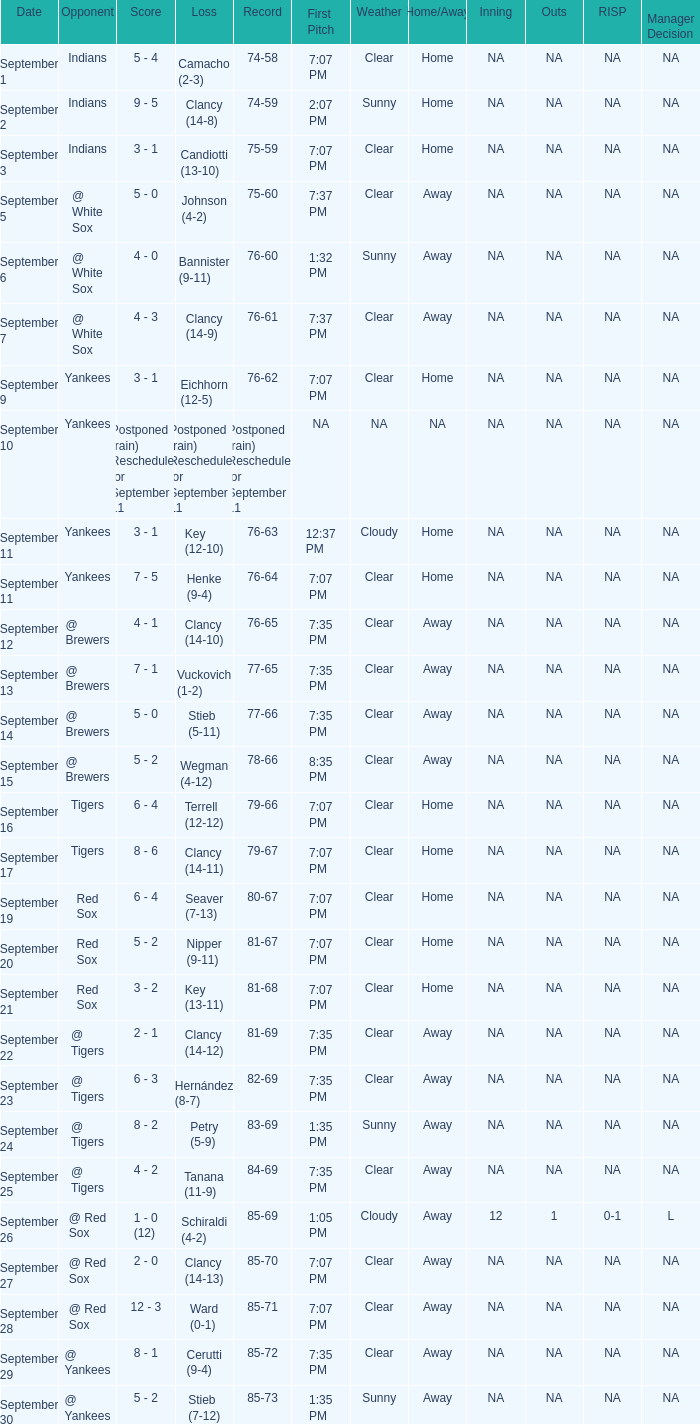What was the date of the game when their record was 84-69? September 25. 